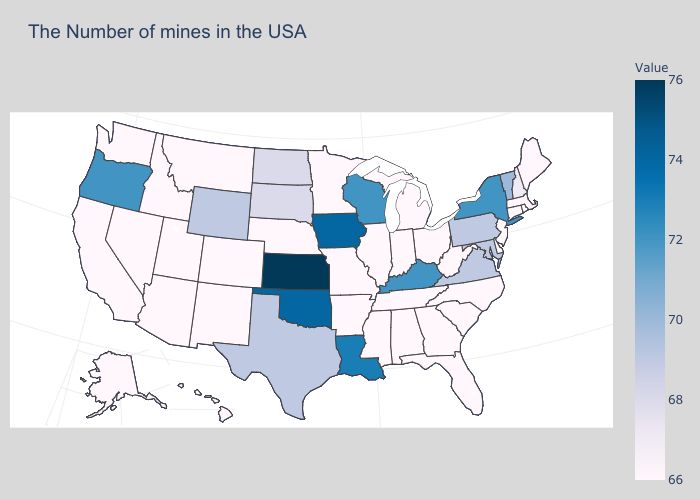Which states have the lowest value in the West?
Keep it brief. Colorado, New Mexico, Utah, Montana, Arizona, Idaho, Nevada, California, Washington, Alaska, Hawaii. Which states have the lowest value in the USA?
Short answer required. Maine, Massachusetts, Rhode Island, Connecticut, New Jersey, Delaware, North Carolina, South Carolina, West Virginia, Ohio, Florida, Georgia, Michigan, Indiana, Alabama, Tennessee, Illinois, Mississippi, Missouri, Arkansas, Minnesota, Nebraska, Colorado, New Mexico, Utah, Montana, Arizona, Idaho, Nevada, California, Washington, Alaska, Hawaii. Among the states that border West Virginia , which have the highest value?
Concise answer only. Kentucky. Among the states that border Mississippi , does Tennessee have the lowest value?
Short answer required. Yes. Among the states that border New Jersey , which have the lowest value?
Keep it brief. Delaware. 